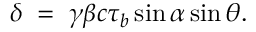<formula> <loc_0><loc_0><loc_500><loc_500>\delta \, = \, \gamma \beta c \tau _ { b } \sin { \alpha } \sin { \theta } .</formula> 